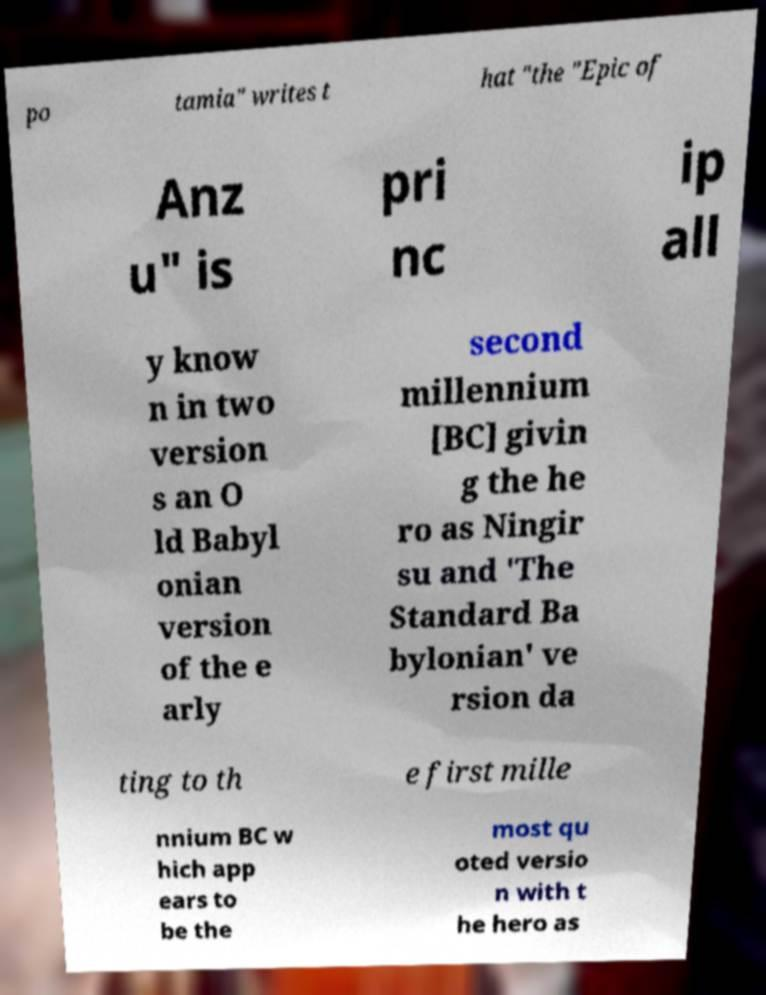For documentation purposes, I need the text within this image transcribed. Could you provide that? po tamia" writes t hat "the "Epic of Anz u" is pri nc ip all y know n in two version s an O ld Babyl onian version of the e arly second millennium [BC] givin g the he ro as Ningir su and 'The Standard Ba bylonian' ve rsion da ting to th e first mille nnium BC w hich app ears to be the most qu oted versio n with t he hero as 